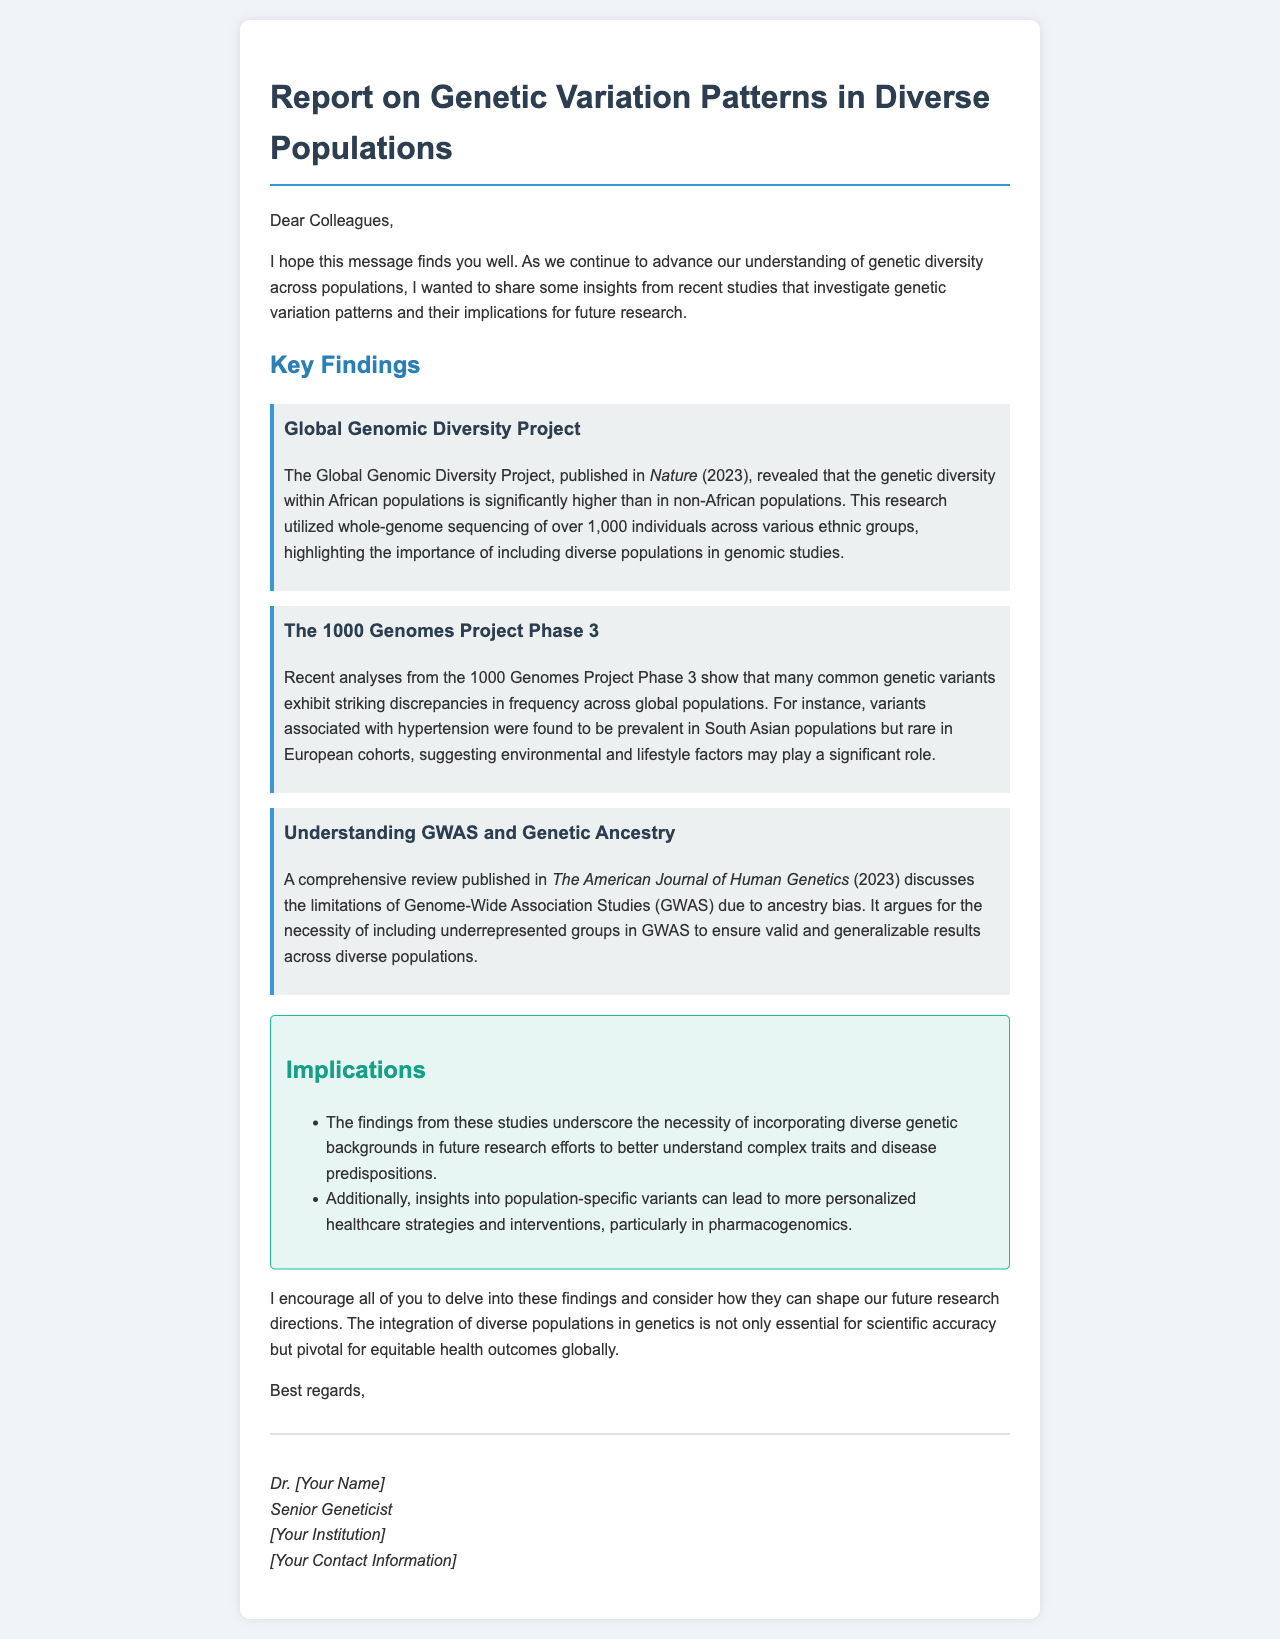what is the title of the document? The title of the document is mentioned at the top of the email, clearly stated to summarize the report's content.
Answer: Report on Genetic Variation Patterns in Diverse Populations who published the Global Genomic Diversity Project findings? The findings of the Global Genomic Diversity Project are published in a well-known scientific journal, mentioned in the key findings section.
Answer: Nature when was the review on GWAS limitations published? The document specifies the year of publication for the review on Genome-Wide Association Studies in the key findings section.
Answer: 2023 what were common genetic variants associated with in South Asian populations? The document indicates an example of common genetic variants and their association by region, particularly as stated in the key findings section.
Answer: hypertension what is one implication of the findings from recent studies? The implications section lists several potential impacts of the findings, focusing on what can be drawn for future research.
Answer: incorporating diverse genetic backgrounds why is it important to include underrepresented groups in GWAS? The reasoning behind this necessity is highlighted in the comprehensive review discussed in the document, linking it to the validity of research results.
Answer: ancestry bias who authored the email? The author of the email is clearly identified in the signature section, allowing readers to know who is sharing these findings.
Answer: Dr. [Your Name] what is the main goal of including diverse populations in genetic studies? The document describes the overall purpose of these actions in a broader context within the implications section.
Answer: equitable health outcomes globally 